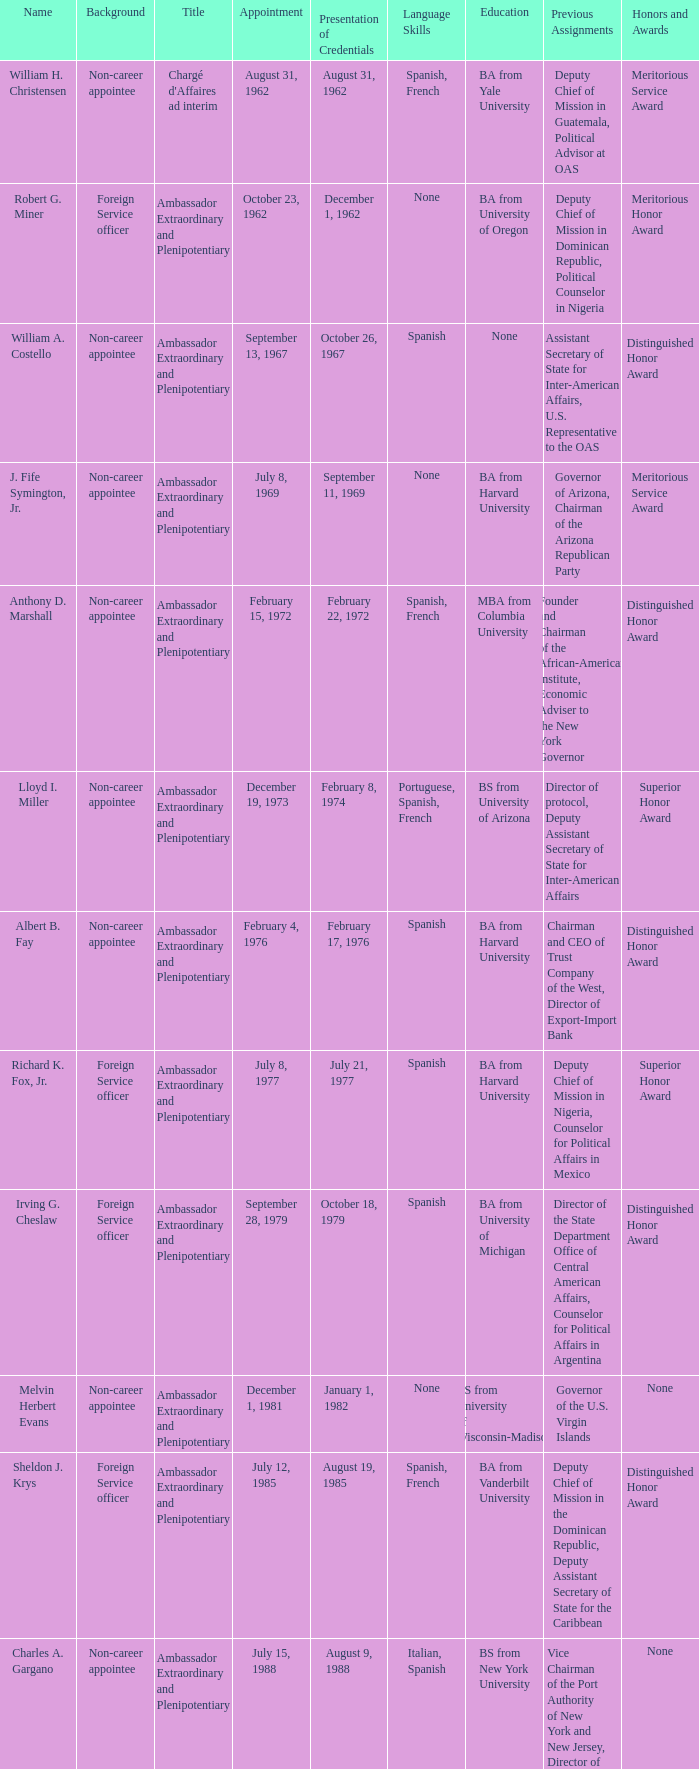When did Robert G. Miner present his credentials? December 1, 1962. 